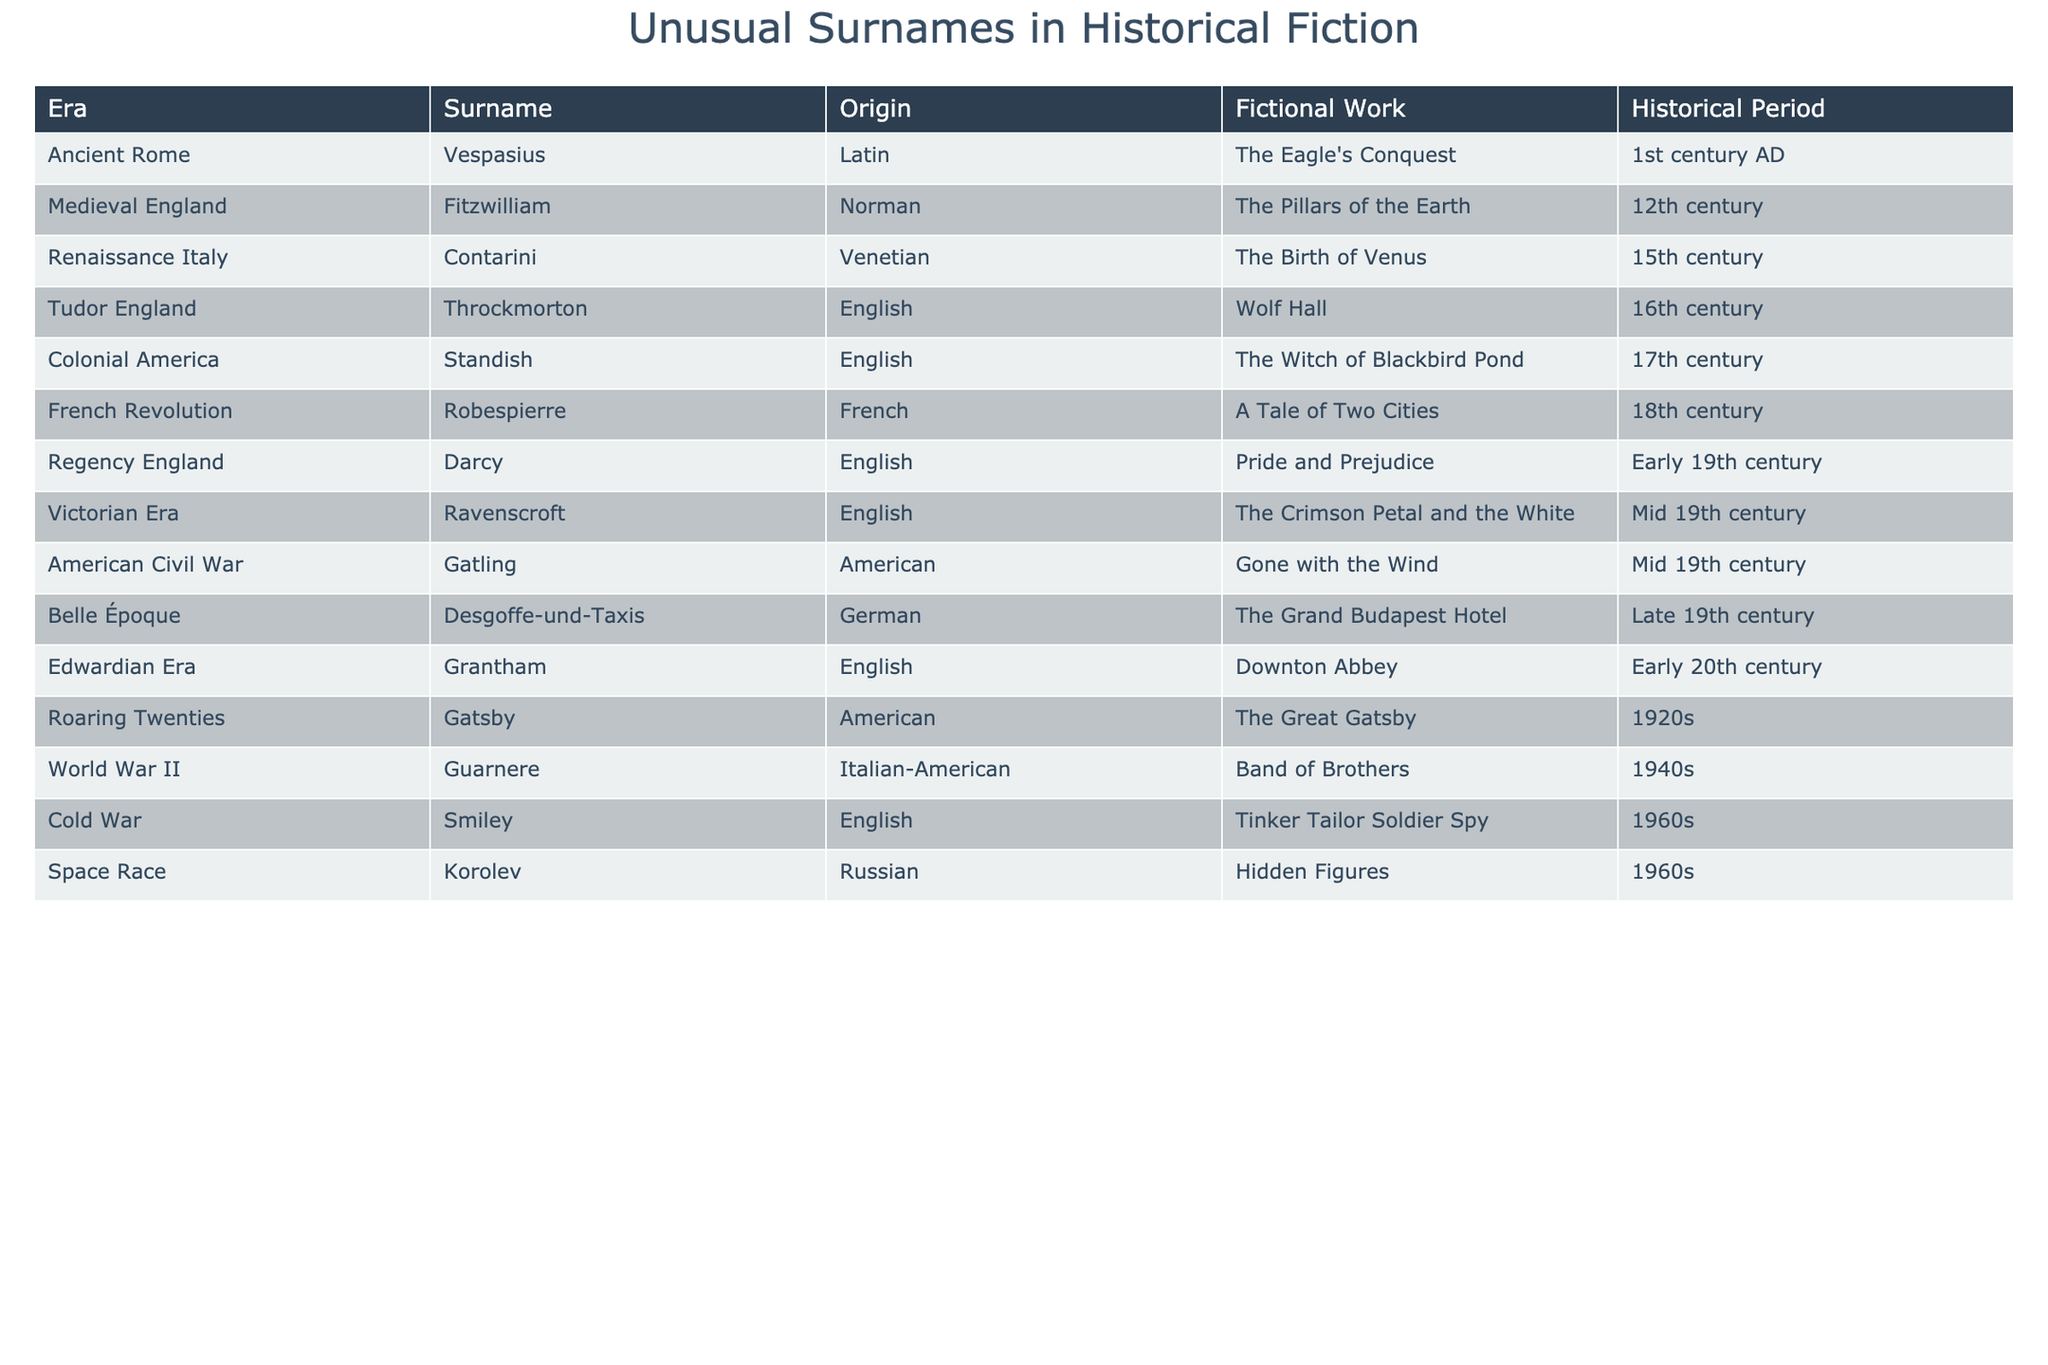What is the surname associated with the Victorian Era? The table lists 'Ravenscroft' as the surname for the Victorian Era, appearing in the work "The Crimson Petal and the White."
Answer: Ravenscroft Which century does the surname 'Robespierre' belong to? According to the table, 'Robespierre' is associated with the 18th century and appears in "A Tale of Two Cities."
Answer: 18th century Is 'Standish' an English surname? The table notes that 'Standish' is categorized as English, associated with the work "The Witch of Blackbird Pond."
Answer: Yes How many surnames are from the Tudor period? The table indicates there is one surname from the Tudor period, 'Throckmorton,' associated with "Wolf Hall."
Answer: 1 What is the origin of the surname 'Gatsby'? The table specifies that 'Gatsby' is of American origin, appearing in "The Great Gatsby."
Answer: American Which surname has a connection to both the Cold War and the Space Race? 'Smiley' is linked to the Cold War, and 'Korolev' is linked to the Space Race; thus, there is no single surname that connects both periods.
Answer: None Which fictional work features the surname 'Contarini'? The table indicates that 'Contarini' is associated with the work "The Birth of Venus."
Answer: The Birth of Venus How many total different origins are represented in the surnames? The table lists seven distinct origins: Latin, Norman, Venetian, English, French, American, and German.
Answer: 7 Which surname from the table is associated with the earliest historical period? The earliest period mentioned in the table is the 1st century AD, linked to the surname 'Vespasius.'
Answer: Vespasius Are there more English surnames or Italian surnames in this table? The table lists six English surnames and one Italian surname, indicating there are more English surnames.
Answer: More English surnames What is the time span between the earliest and the latest surnames in this table? The earliest surname from the 1st century AD and the latest from the 1960s would give a time span of approximately 1960 years.
Answer: 1960 years 